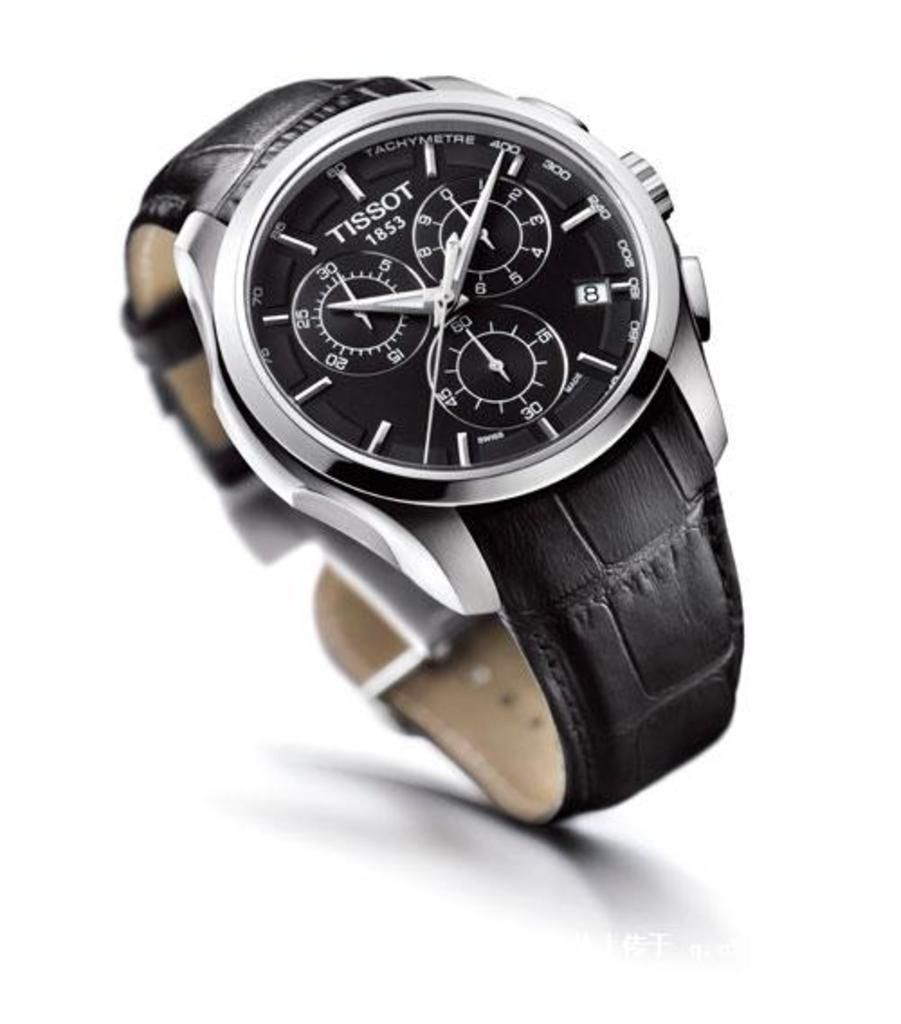<image>
Provide a brief description of the given image. A Tissot watch has the date 1853 on the face. 